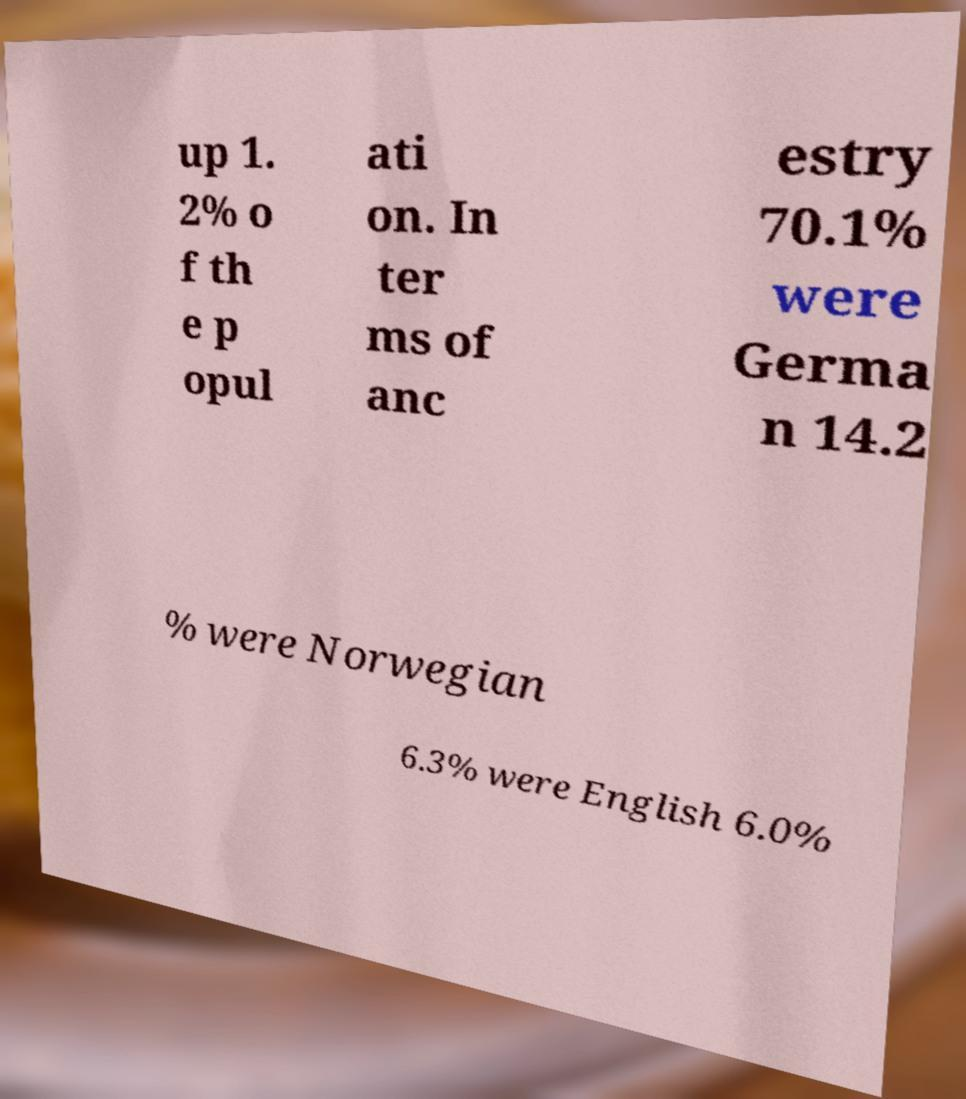Can you accurately transcribe the text from the provided image for me? up 1. 2% o f th e p opul ati on. In ter ms of anc estry 70.1% were Germa n 14.2 % were Norwegian 6.3% were English 6.0% 